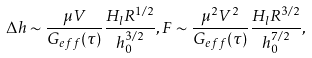<formula> <loc_0><loc_0><loc_500><loc_500>\Delta h \sim \frac { \mu V } { G _ { e f f } ( \tau ) } \frac { H _ { l } R ^ { 1 / 2 } } { h _ { 0 } ^ { 3 / 2 } } , F \sim \frac { \mu ^ { 2 } V ^ { 2 } } { G _ { e f f } ( \tau ) } \frac { H _ { l } R ^ { 3 / 2 } } { h _ { 0 } ^ { 7 / 2 } } ,</formula> 